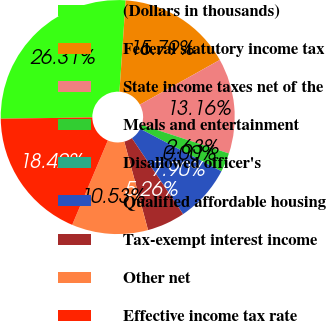Convert chart. <chart><loc_0><loc_0><loc_500><loc_500><pie_chart><fcel>(Dollars in thousands)<fcel>Federal statutory income tax<fcel>State income taxes net of the<fcel>Meals and entertainment<fcel>Disallowed officer's<fcel>Qualified affordable housing<fcel>Tax-exempt interest income<fcel>Other net<fcel>Effective income tax rate<nl><fcel>26.31%<fcel>15.79%<fcel>13.16%<fcel>2.63%<fcel>0.0%<fcel>7.9%<fcel>5.26%<fcel>10.53%<fcel>18.42%<nl></chart> 